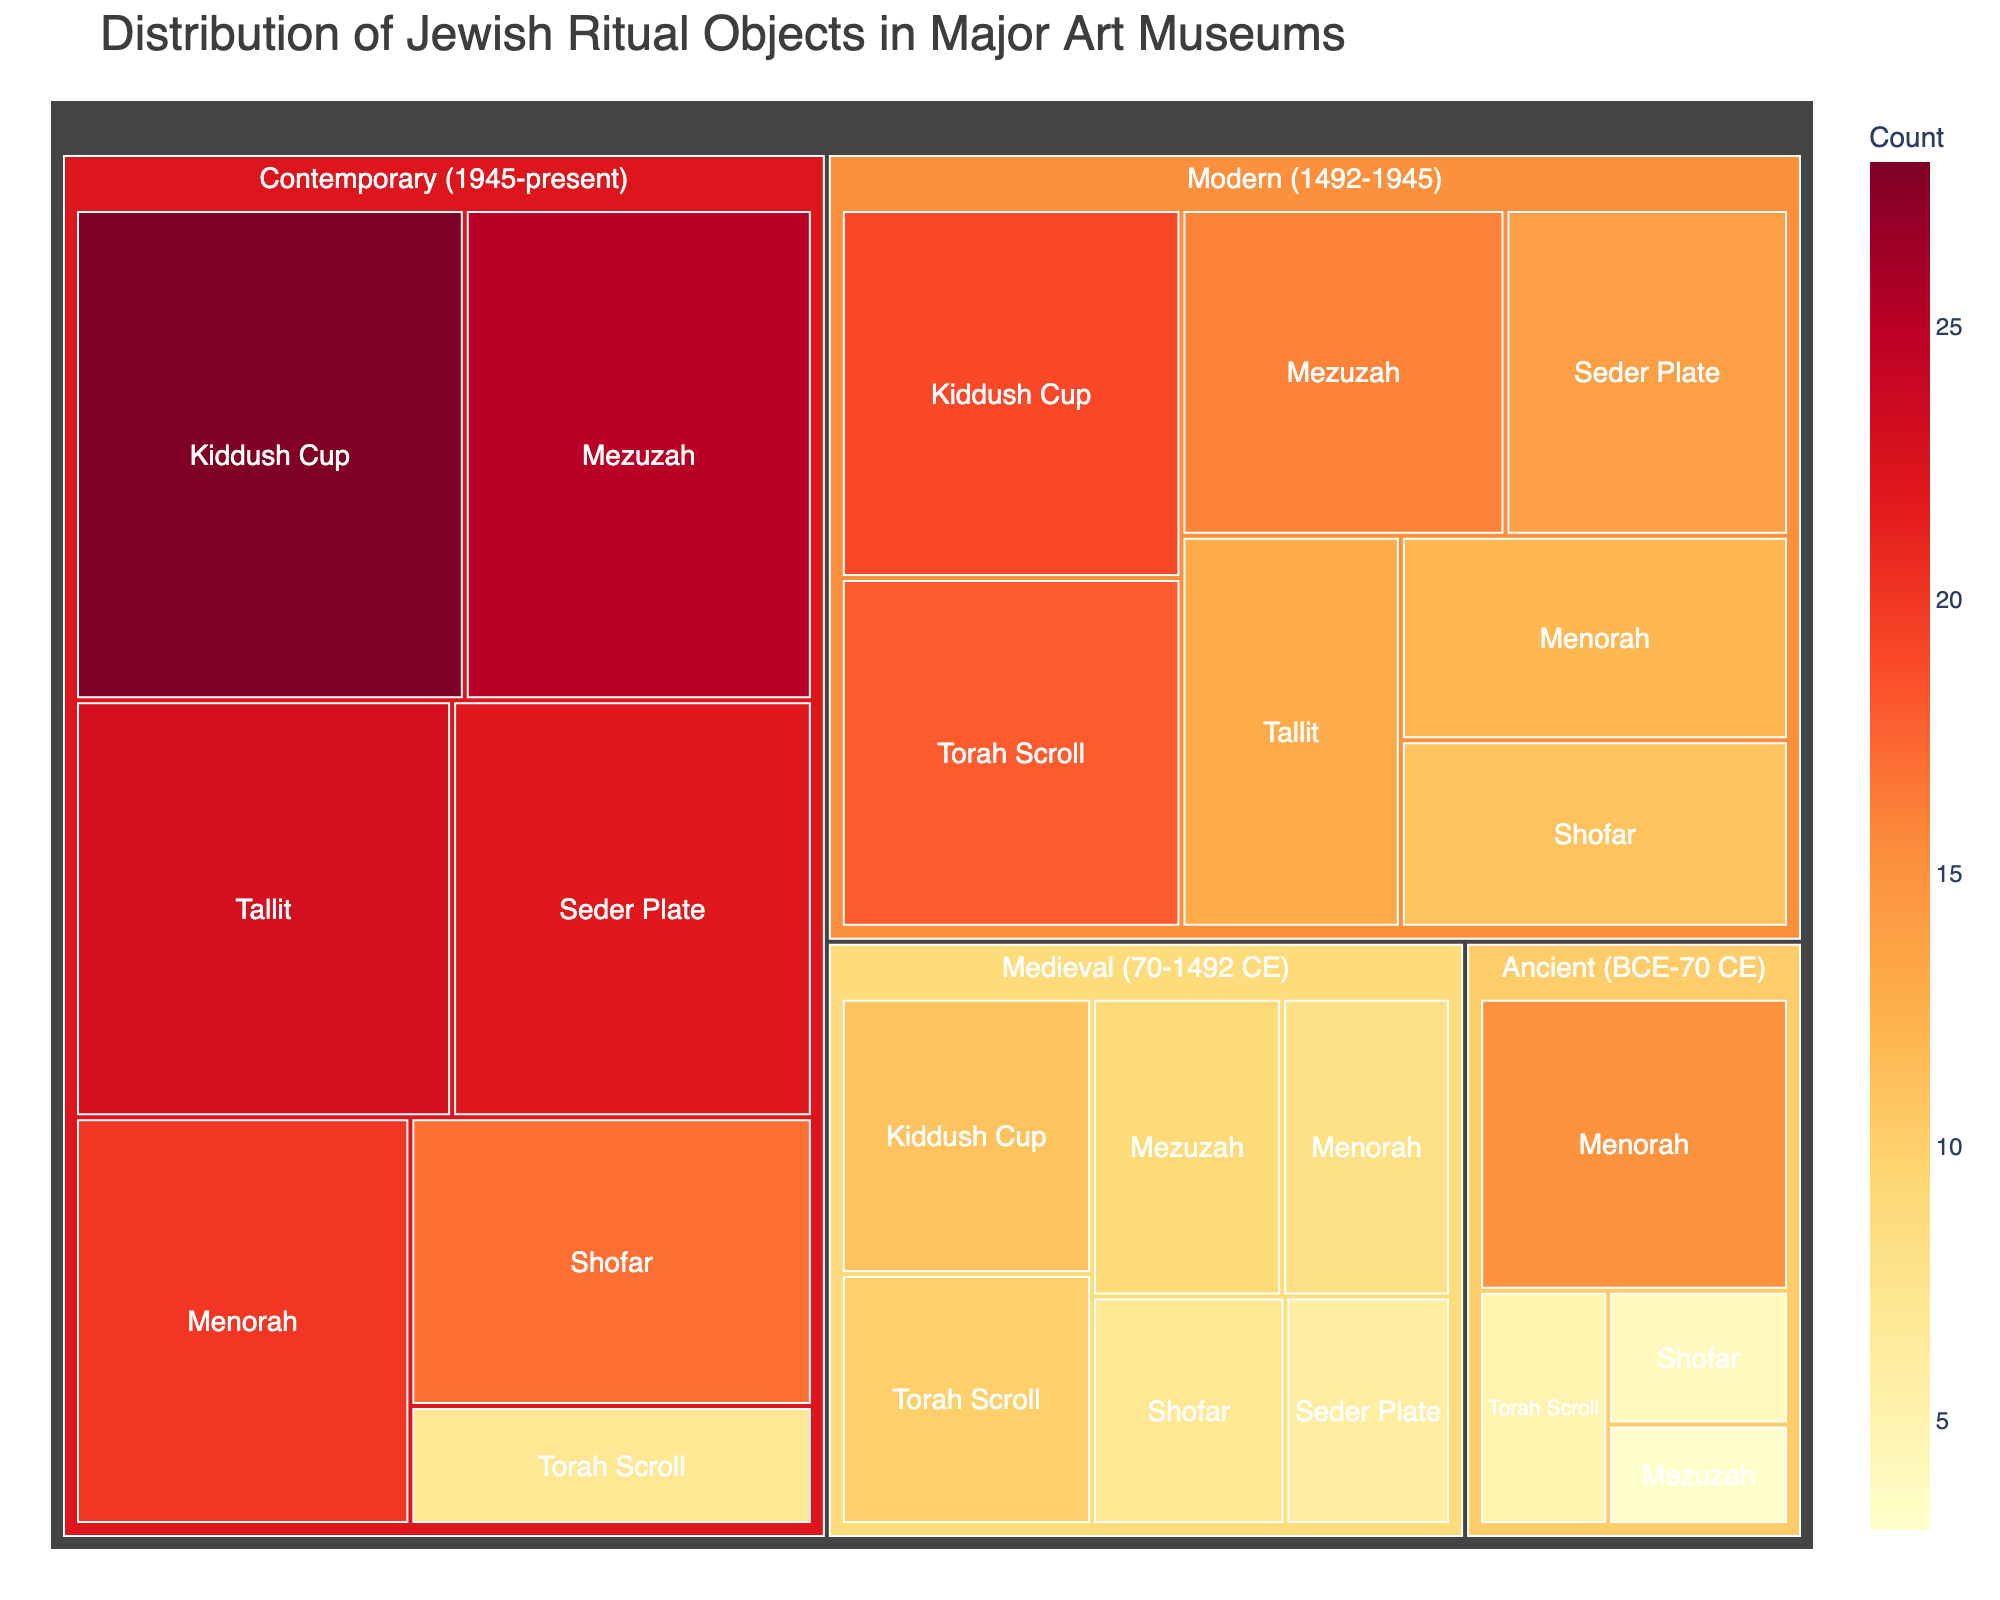how many menorahs are from the contemporary era? Look at the section representing the Menorah from the Contemporary era on the treemap. The Count value shows 20.
Answer: 20 Which era has the most Torah Scrolls? Compare the Count values for Torah Scrolls across all historical eras. The Modern era has the highest count with 18 Torah Scrolls.
Answer: Modern Which object type has the largest count in the Ancient era? In the Ancient era, compare the counts of all objects. The Menorah has the highest count with 15.
Answer: Menorah What's the total count of Seder Plates across all eras? Add the counts of Seder Plates from all historical eras: 6 (Medieval) + 14 (Modern) + 22 (Contemporary). The sum is 42.
Answer: 42 How many Mezuzahs and Shofars are there in the Contemporary era combined? Sum the counts of Mezuzahs and Shofars in the Contemporary era: 25 (Mezuzah) + 17 (Shofar). This equals 42.
Answer: 42 Which object type has the least representation in the Modern era? Compare the counts for all object types in the Modern era. The Tallit has the lowest count with 13.
Answer: Tallit What is the difference in count between the contemporary and ancient Menorahs? Subtract the count of Ancient Menorahs (15) from the count of Contemporary Menorahs (20). The difference is 5.
Answer: 5 Which two object types have the same count in any era? Look for object types with the same count within any specific era. In the Medieval era, the Shofar and Menorah both have a count of 8.
Answer: Shofar and Menorah What is the most common object type in the entire dataset? Sum the counts for each object type across all eras. Mezuzah has the highest total count when summed across its eras.
Answer: Mezuzah 